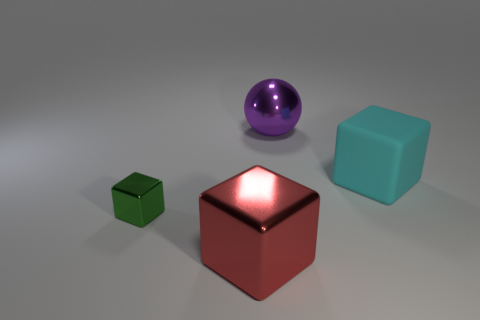Add 4 purple shiny things. How many objects exist? 8 Subtract all balls. How many objects are left? 3 Subtract 0 gray blocks. How many objects are left? 4 Subtract all rubber objects. Subtract all purple spheres. How many objects are left? 2 Add 4 green things. How many green things are left? 5 Add 3 green blocks. How many green blocks exist? 4 